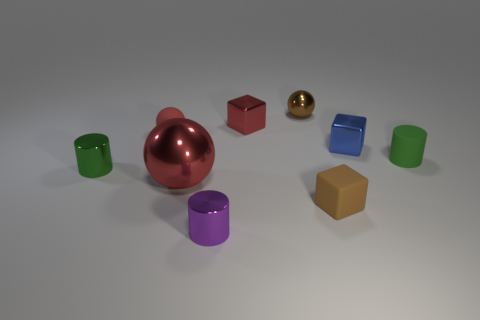Subtract all green cylinders. Subtract all gray blocks. How many cylinders are left? 1 Subtract all blocks. How many objects are left? 6 Subtract 1 brown blocks. How many objects are left? 8 Subtract all small blue metal cubes. Subtract all metal objects. How many objects are left? 2 Add 8 small green metallic things. How many small green metallic things are left? 9 Add 3 large objects. How many large objects exist? 4 